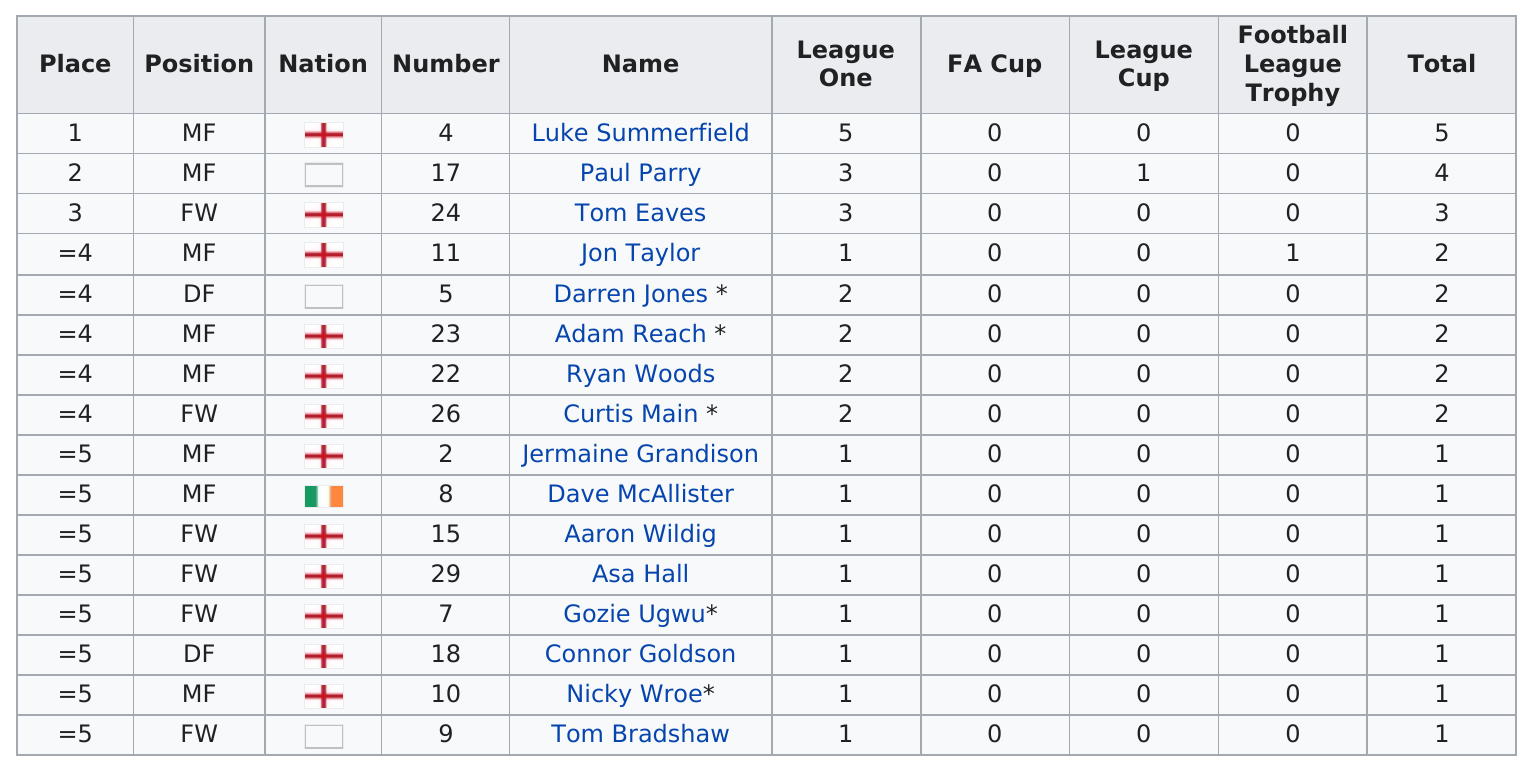Give some essential details in this illustration. Luke Summerfield is the only person in history to have recorded more than four assists. In total, the top three players combined for 12 assists. The next name listed after Jon Taylor is Darren Jones. It is stated that Jon Taylor is preceded by Tom Eaves in the list. After Paul Parry, who was the next person in total assists? The answer is Tom Eaves. 